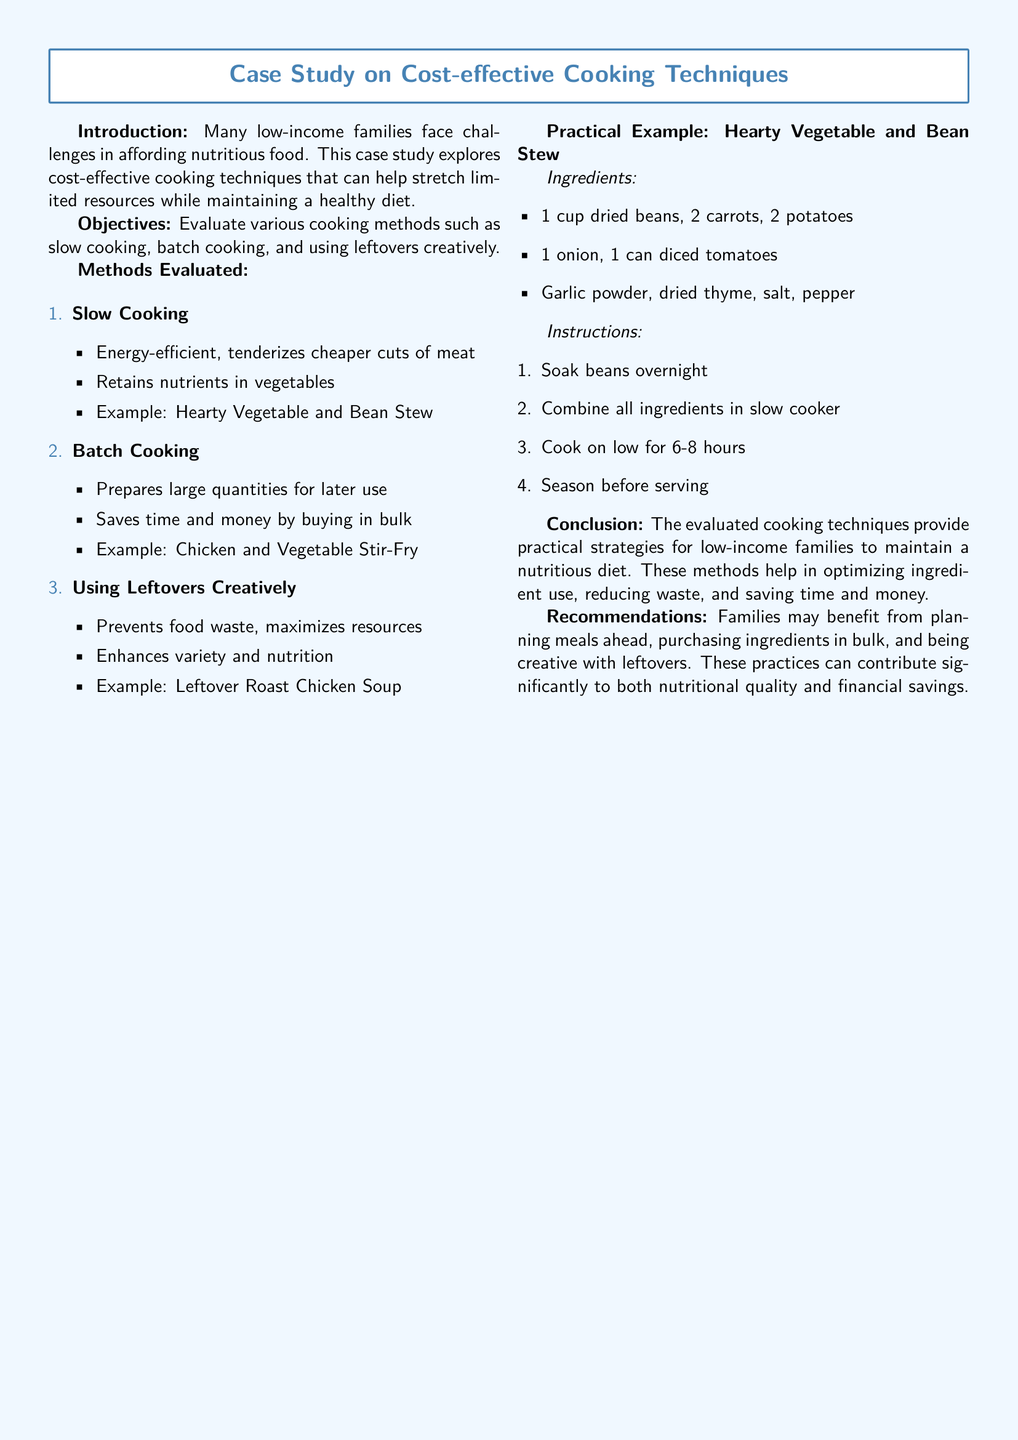What cooking method is energy-efficient? The cooking method that is energy-efficient is slow cooking, which also tenderizes cheaper cuts of meat.
Answer: slow cooking What is the example recipe for batch cooking? The example recipe for batch cooking is chicken and vegetable stir-fry, which prepares large quantities for later use.
Answer: chicken and vegetable stir-fry How long should the Hearty Vegetable and Bean Stew be cooked on low? The Hearty Vegetable and Bean Stew should be cooked on low for 6-8 hours according to the cooking instructions.
Answer: 6-8 hours What ingredients are needed for the Hearty Vegetable and Bean Stew? The ingredients include 1 cup dried beans, 2 carrots, 2 potatoes, 1 onion, and 1 can diced tomatoes, along with seasonings.
Answer: 1 cup dried beans, 2 carrots, 2 potatoes, 1 onion, 1 can diced tomatoes What is the main objective of the case study? The main objective of the case study is to evaluate various cooking methods such as slow cooking, batch cooking, and using leftovers creatively.
Answer: evaluate various cooking methods 